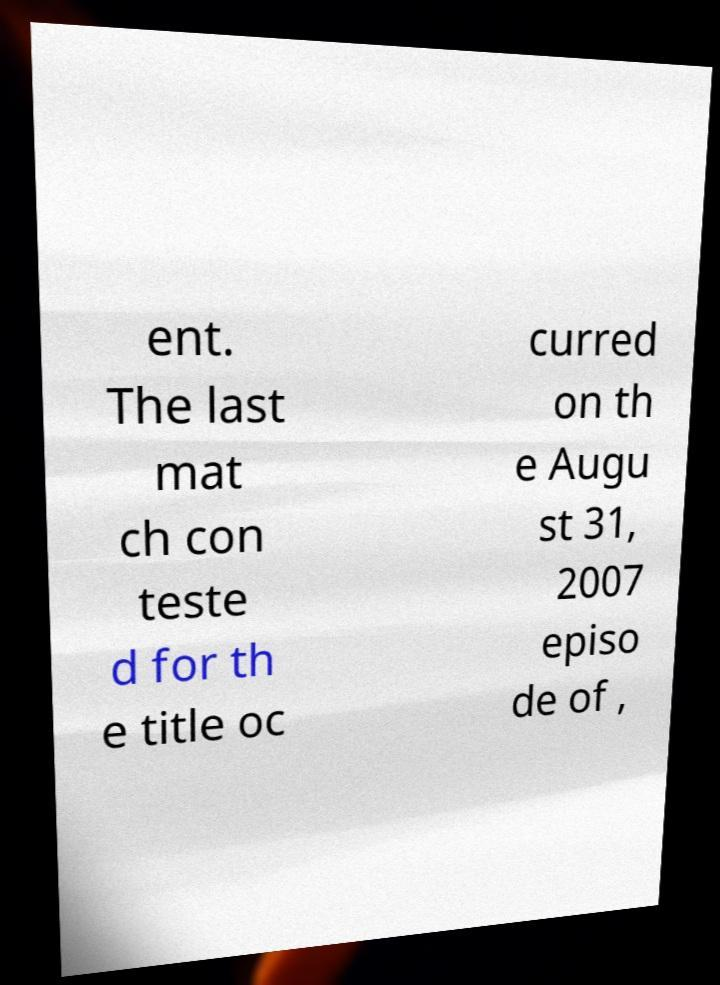Please read and relay the text visible in this image. What does it say? ent. The last mat ch con teste d for th e title oc curred on th e Augu st 31, 2007 episo de of , 